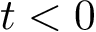Convert formula to latex. <formula><loc_0><loc_0><loc_500><loc_500>t < 0</formula> 